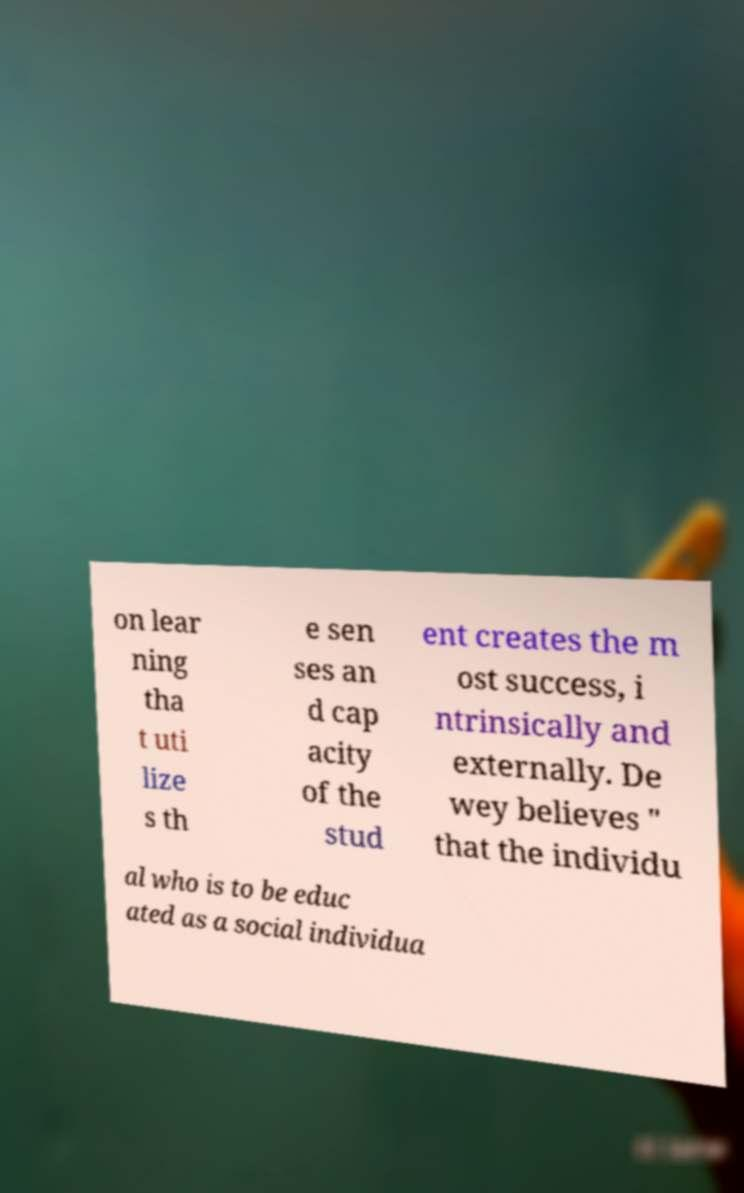For documentation purposes, I need the text within this image transcribed. Could you provide that? on lear ning tha t uti lize s th e sen ses an d cap acity of the stud ent creates the m ost success, i ntrinsically and externally. De wey believes " that the individu al who is to be educ ated as a social individua 